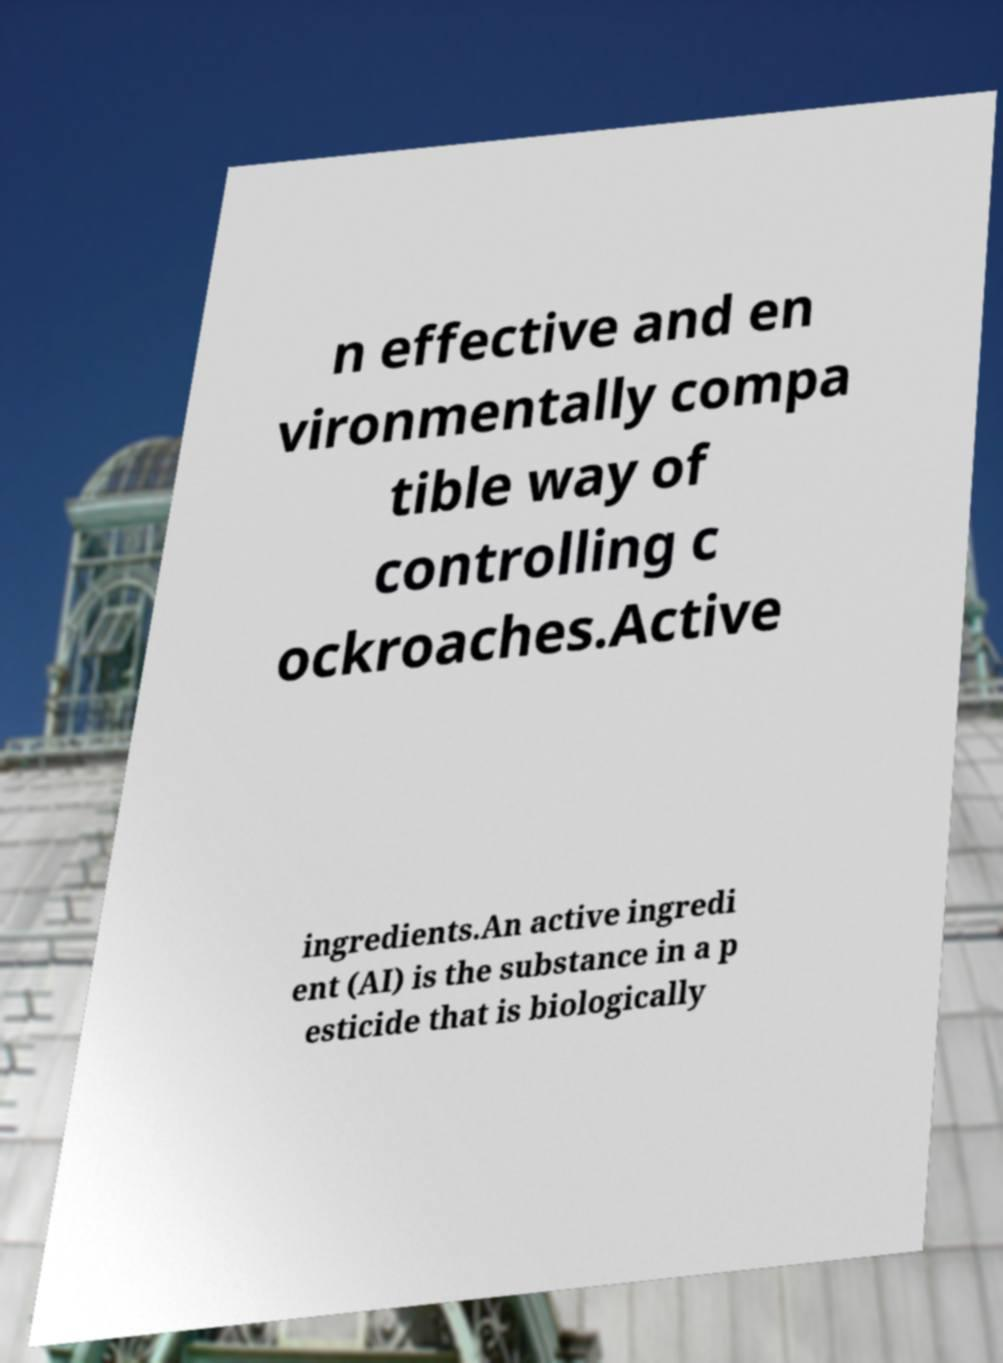For documentation purposes, I need the text within this image transcribed. Could you provide that? n effective and en vironmentally compa tible way of controlling c ockroaches.Active ingredients.An active ingredi ent (AI) is the substance in a p esticide that is biologically 